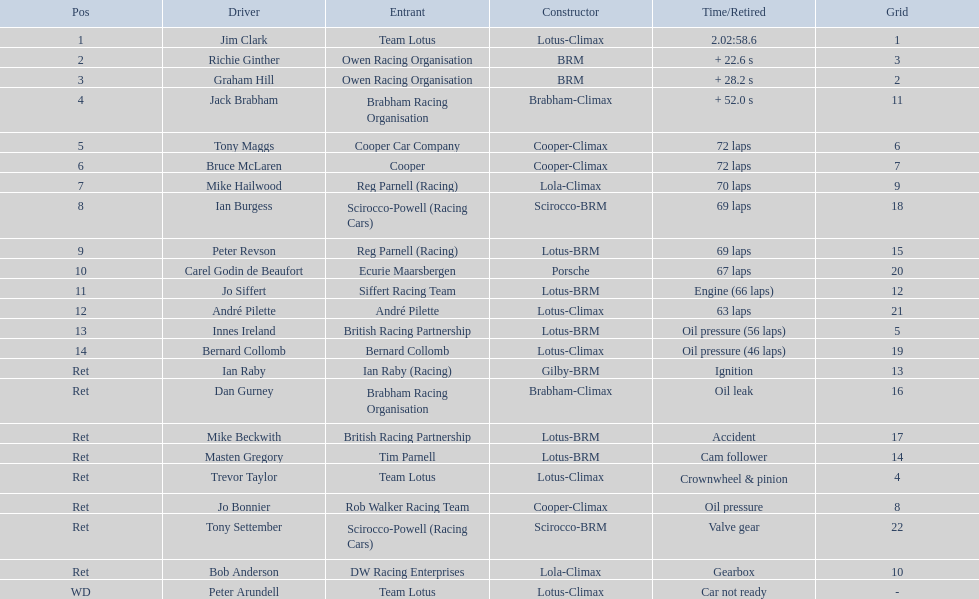Who all maneuver automobiles made by climax? Jim Clark, Jack Brabham, Tony Maggs, Bruce McLaren, Mike Hailwood, André Pilette, Bernard Collomb, Dan Gurney, Trevor Taylor, Jo Bonnier, Bob Anderson, Peter Arundell. Which motorist's climax-assembled cars initiated in the top 10 on the grid? Jim Clark, Tony Maggs, Bruce McLaren, Mike Hailwood, Jo Bonnier, Bob Anderson. Of the top 10 beginning climax-assembled drivers, which ones failed to finish the race? Jo Bonnier, Bob Anderson. What was the engine-associated malfunction that removed the driver of the climax-assembled car that did not finish despite starting in the top 10? Oil pressure. 